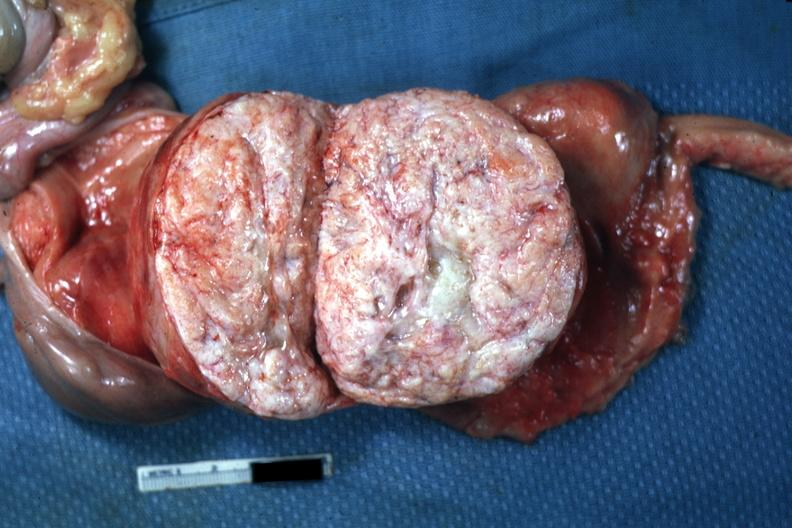s stillborn cord around neck present?
Answer the question using a single word or phrase. No 